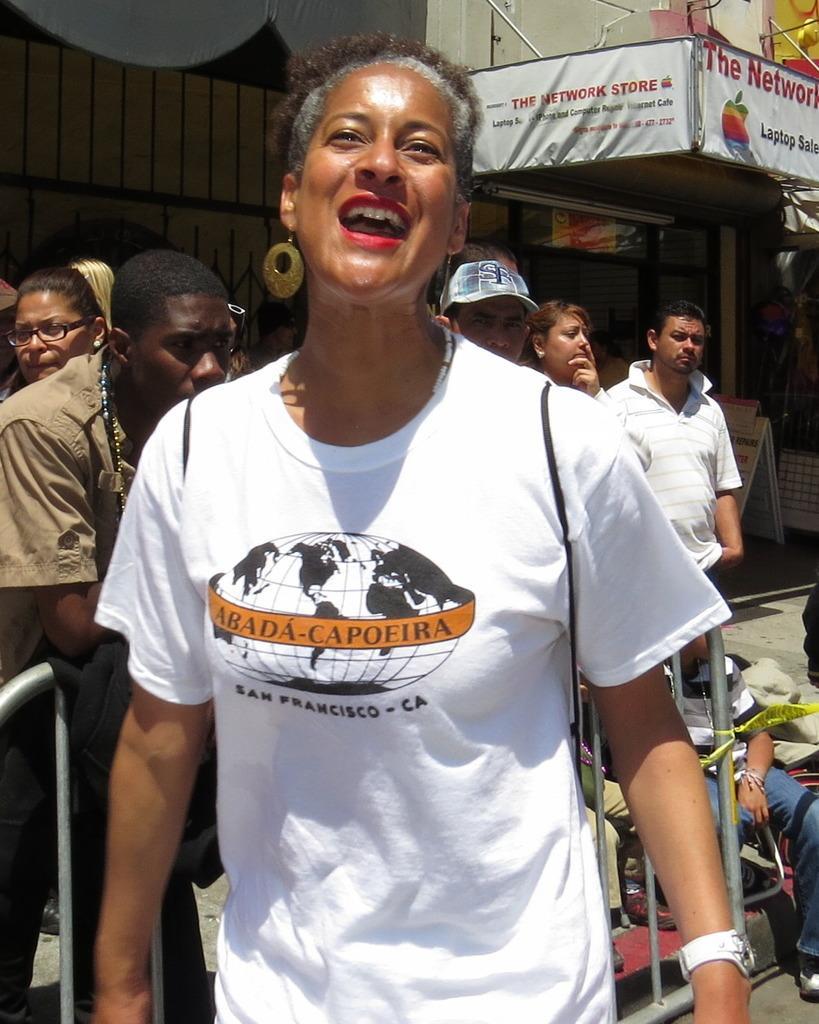Can you describe this image briefly? In this image I can see few people are wearing different color dresses. I can see the buildings, boards, glass walls and few objects. 